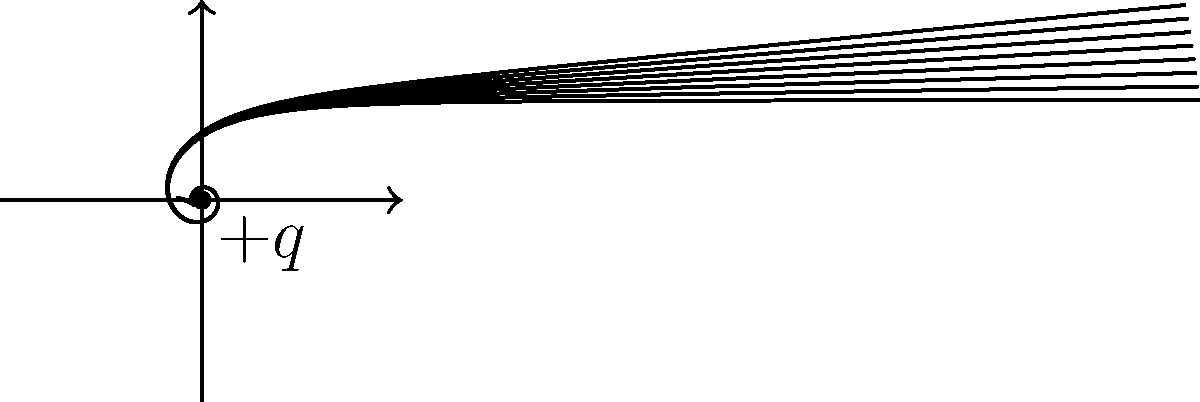As a neuroscientist studying memory formation in the developing brain, you're exploring the analogy between neuronal signaling and electric fields. Consider a positively charged particle $+q$ at the origin. How would you describe the electric field lines around this particle, and what implications might this have for understanding the propagation of electrical signals in neurons? To answer this question, let's break it down step-by-step:

1. Electric field lines for a positive charge:
   - The lines radiate outward from the charge in all directions.
   - They are straight lines in a radial pattern.
   - The lines start from the charge and extend to infinity.

2. Properties of electric field lines:
   - The density of lines represents the strength of the field.
   - The field is strongest near the charge and weakens with distance.
   - The direction of the field at any point is tangent to the field line at that point.

3. Mathematical representation:
   - The electric field $\vec{E}$ at a distance $r$ from a point charge $q$ is given by:
     $$\vec{E} = \frac{1}{4\pi\epsilon_0} \frac{q}{r^2} \hat{r}$$
   where $\epsilon_0$ is the permittivity of free space and $\hat{r}$ is the unit vector pointing radially outward.

4. Analogy to neuronal signaling:
   - Neurons generate electrical signals through ion movements.
   - The propagation of these signals can be likened to the spread of an electric field.
   - The strength of the signal decreases with distance from the source, similar to how the electric field weakens with distance from the charge.

5. Implications for neuronal signaling:
   - Understanding electric fields can help model how electrical signals spread in neurons.
   - The radial nature of the field might explain why synaptic connections closer to the cell body have a stronger influence.
   - The decrease in field strength with distance could relate to the need for signal amplification in long axons.

This analogy between electric fields and neuronal signaling can provide insights into how information is transmitted and processed in the developing brain, potentially shedding light on memory formation and consolidation mechanisms.
Answer: Radial outward lines; strength decreases with distance; analogous to neuronal signal propagation. 